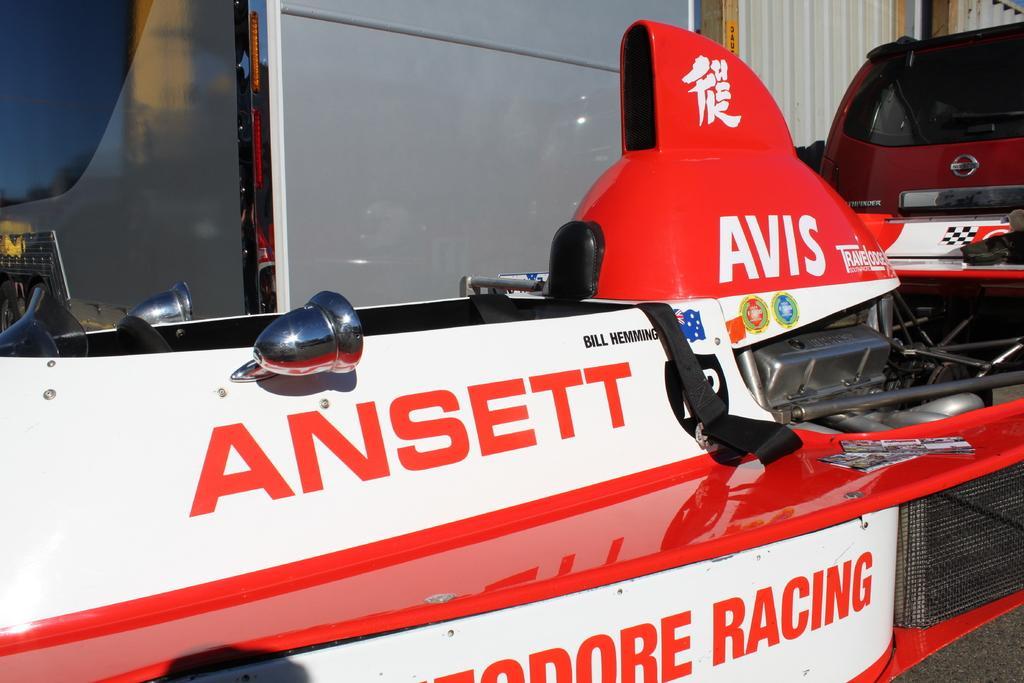How would you summarize this image in a sentence or two? In this image I can see a vehicle like thing in the front and on it I can see something is written. On the top right side of the image I can see tin walls. 